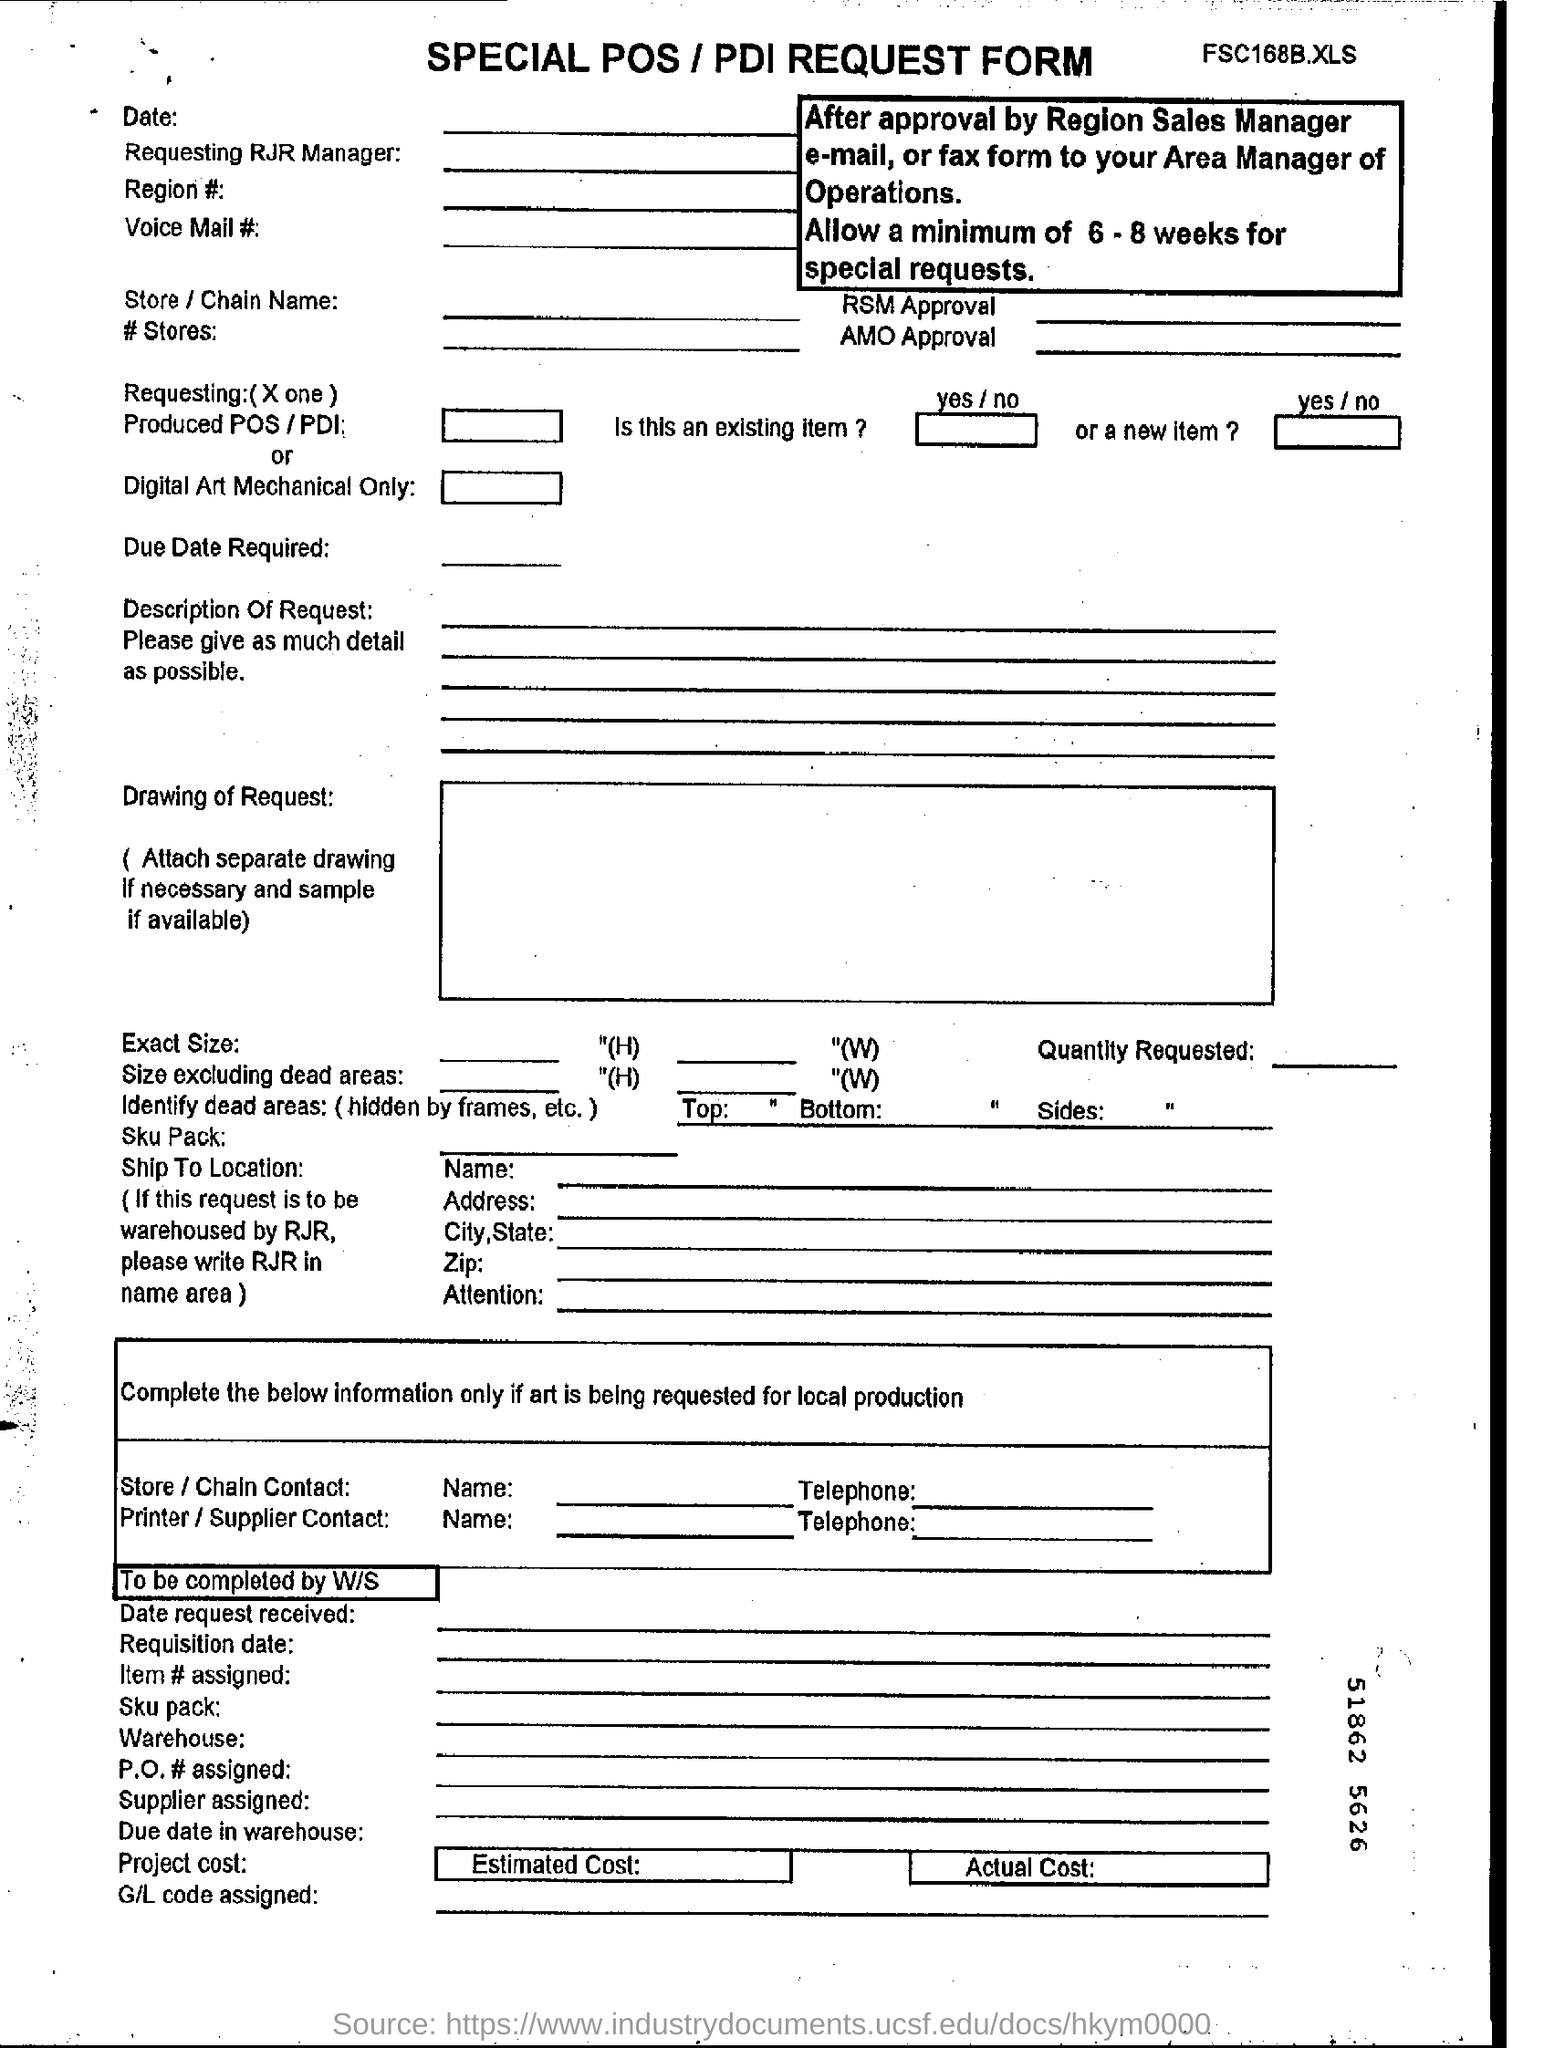Outline some significant characteristics in this image. This declaration is a Special POS/PDI Request Form. The minimum time allowed for special requests is six to eight weeks, and this requirement applies when making a request. 